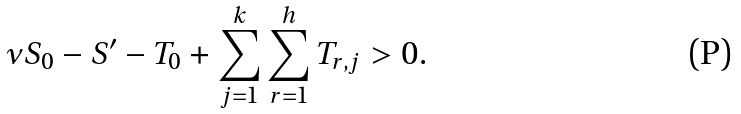Convert formula to latex. <formula><loc_0><loc_0><loc_500><loc_500>\nu S _ { 0 } - S ^ { \prime } - T _ { 0 } + \sum _ { j = 1 } ^ { k } \sum _ { r = 1 } ^ { h } T _ { r , j } > 0 .</formula> 